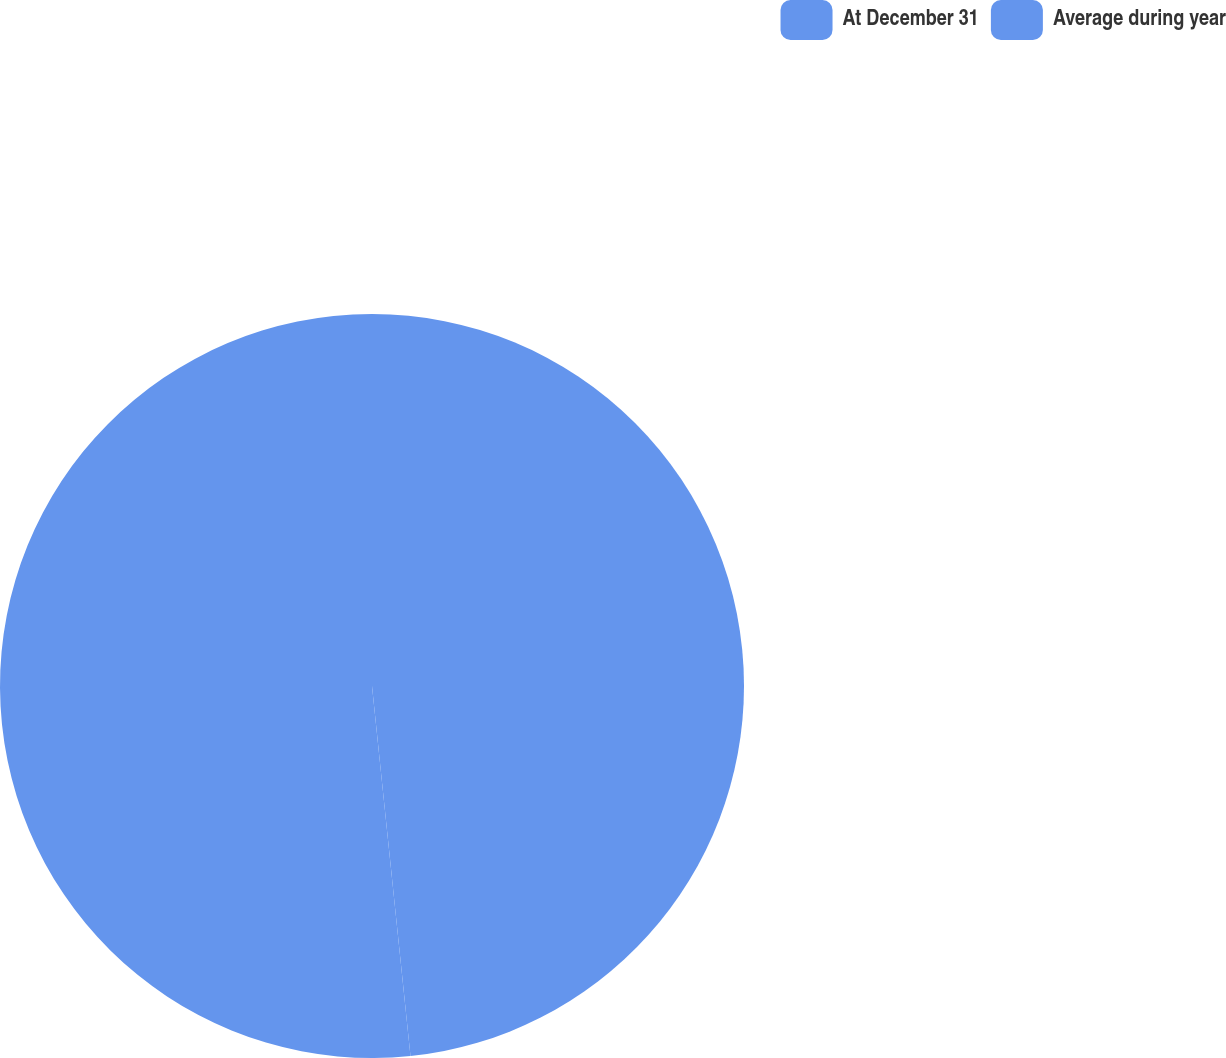Convert chart. <chart><loc_0><loc_0><loc_500><loc_500><pie_chart><fcel>At December 31<fcel>Average during year<nl><fcel>48.35%<fcel>51.65%<nl></chart> 